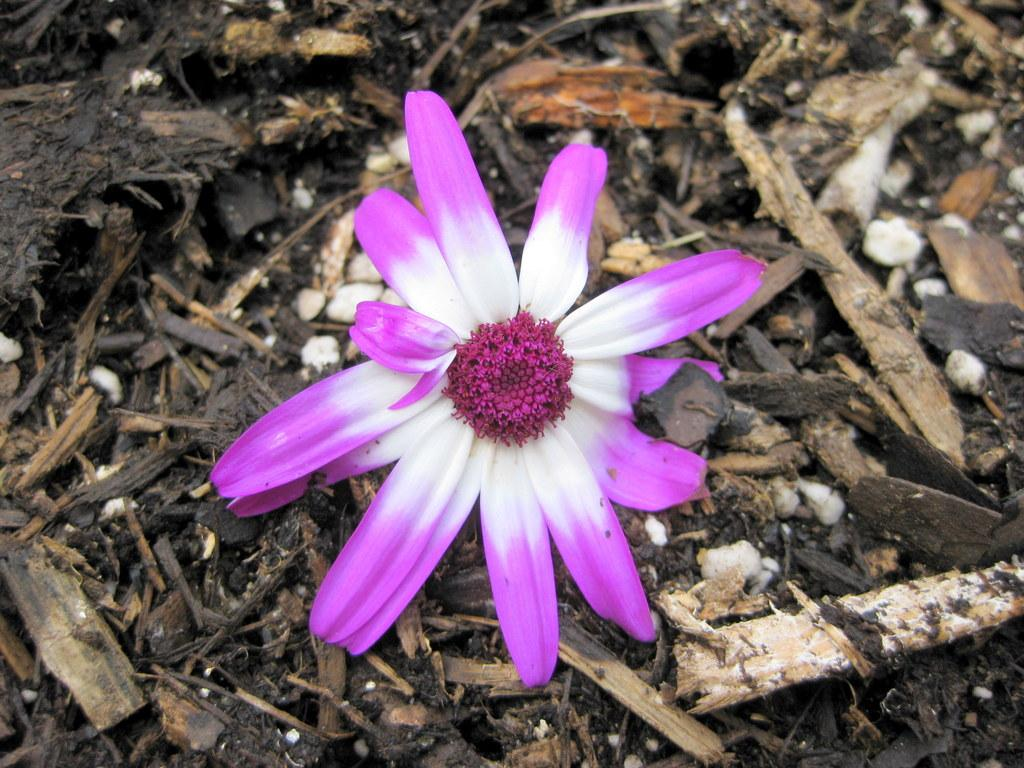What is the main subject of the picture? The main subject of the picture is a flower. Are there any other objects or elements in the picture besides the flower? Yes, there are broken wooden pieces in the picture. What type of tramp can be seen in the picture? There is no tramp present in the picture; it features a flower and broken wooden pieces. How many clouds are visible in the picture? There are no clouds visible in the picture, as it only contains a flower and broken wooden pieces. 